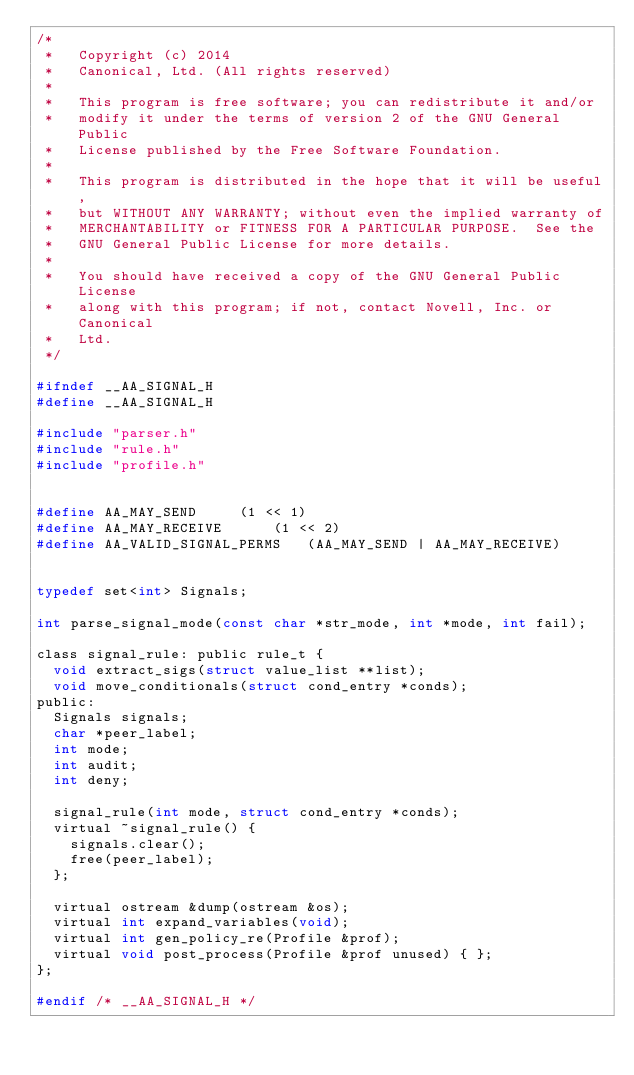<code> <loc_0><loc_0><loc_500><loc_500><_C_>/*
 *   Copyright (c) 2014
 *   Canonical, Ltd. (All rights reserved)
 *
 *   This program is free software; you can redistribute it and/or
 *   modify it under the terms of version 2 of the GNU General Public
 *   License published by the Free Software Foundation.
 *
 *   This program is distributed in the hope that it will be useful,
 *   but WITHOUT ANY WARRANTY; without even the implied warranty of
 *   MERCHANTABILITY or FITNESS FOR A PARTICULAR PURPOSE.  See the
 *   GNU General Public License for more details.
 *
 *   You should have received a copy of the GNU General Public License
 *   along with this program; if not, contact Novell, Inc. or Canonical
 *   Ltd.
 */

#ifndef __AA_SIGNAL_H
#define __AA_SIGNAL_H

#include "parser.h"
#include "rule.h"
#include "profile.h"


#define AA_MAY_SEND			(1 << 1)
#define AA_MAY_RECEIVE			(1 << 2)
#define AA_VALID_SIGNAL_PERMS		(AA_MAY_SEND | AA_MAY_RECEIVE)


typedef set<int> Signals;

int parse_signal_mode(const char *str_mode, int *mode, int fail);

class signal_rule: public rule_t {
	void extract_sigs(struct value_list **list);
	void move_conditionals(struct cond_entry *conds);
public:
	Signals signals;
	char *peer_label;
	int mode;
	int audit;
	int deny;

	signal_rule(int mode, struct cond_entry *conds);
	virtual ~signal_rule() {
		signals.clear();
		free(peer_label);
	};

	virtual ostream &dump(ostream &os);
	virtual int expand_variables(void);
	virtual int gen_policy_re(Profile &prof);
	virtual void post_process(Profile &prof unused) { };
};

#endif /* __AA_SIGNAL_H */
</code> 